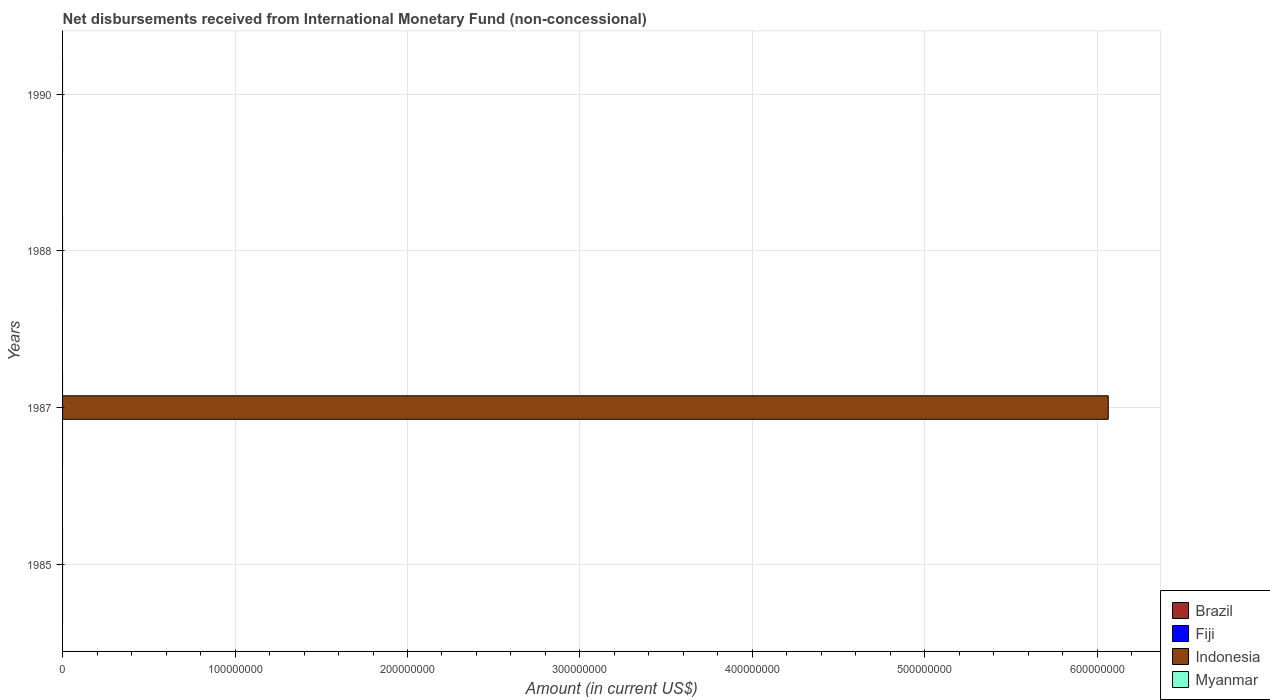How many different coloured bars are there?
Provide a succinct answer. 1. Are the number of bars per tick equal to the number of legend labels?
Your response must be concise. No. Are the number of bars on each tick of the Y-axis equal?
Ensure brevity in your answer.  No. In how many cases, is the number of bars for a given year not equal to the number of legend labels?
Offer a very short reply. 4. Across all years, what is the maximum amount of disbursements received from International Monetary Fund in Indonesia?
Provide a succinct answer. 6.06e+08. What is the total amount of disbursements received from International Monetary Fund in Brazil in the graph?
Make the answer very short. 0. What is the difference between the amount of disbursements received from International Monetary Fund in Indonesia in 1990 and the amount of disbursements received from International Monetary Fund in Myanmar in 1985?
Your response must be concise. 0. What is the average amount of disbursements received from International Monetary Fund in Indonesia per year?
Offer a very short reply. 1.52e+08. In how many years, is the amount of disbursements received from International Monetary Fund in Fiji greater than 100000000 US$?
Your answer should be very brief. 0. What is the difference between the highest and the lowest amount of disbursements received from International Monetary Fund in Indonesia?
Your answer should be very brief. 6.06e+08. In how many years, is the amount of disbursements received from International Monetary Fund in Brazil greater than the average amount of disbursements received from International Monetary Fund in Brazil taken over all years?
Give a very brief answer. 0. Is it the case that in every year, the sum of the amount of disbursements received from International Monetary Fund in Myanmar and amount of disbursements received from International Monetary Fund in Fiji is greater than the sum of amount of disbursements received from International Monetary Fund in Indonesia and amount of disbursements received from International Monetary Fund in Brazil?
Keep it short and to the point. No. Is it the case that in every year, the sum of the amount of disbursements received from International Monetary Fund in Brazil and amount of disbursements received from International Monetary Fund in Indonesia is greater than the amount of disbursements received from International Monetary Fund in Fiji?
Your answer should be compact. No. How many bars are there?
Offer a very short reply. 1. Does the graph contain grids?
Provide a short and direct response. Yes. Where does the legend appear in the graph?
Offer a very short reply. Bottom right. What is the title of the graph?
Make the answer very short. Net disbursements received from International Monetary Fund (non-concessional). What is the label or title of the Y-axis?
Offer a terse response. Years. What is the Amount (in current US$) of Fiji in 1987?
Your answer should be very brief. 0. What is the Amount (in current US$) of Indonesia in 1987?
Your answer should be compact. 6.06e+08. What is the Amount (in current US$) in Myanmar in 1987?
Provide a succinct answer. 0. What is the Amount (in current US$) of Fiji in 1988?
Make the answer very short. 0. What is the Amount (in current US$) of Indonesia in 1988?
Give a very brief answer. 0. What is the Amount (in current US$) in Myanmar in 1988?
Your response must be concise. 0. What is the Amount (in current US$) in Myanmar in 1990?
Offer a very short reply. 0. Across all years, what is the maximum Amount (in current US$) in Indonesia?
Your answer should be compact. 6.06e+08. Across all years, what is the minimum Amount (in current US$) of Indonesia?
Offer a very short reply. 0. What is the total Amount (in current US$) of Indonesia in the graph?
Your response must be concise. 6.06e+08. What is the total Amount (in current US$) in Myanmar in the graph?
Your response must be concise. 0. What is the average Amount (in current US$) of Indonesia per year?
Ensure brevity in your answer.  1.52e+08. What is the average Amount (in current US$) in Myanmar per year?
Give a very brief answer. 0. What is the difference between the highest and the lowest Amount (in current US$) of Indonesia?
Offer a very short reply. 6.06e+08. 